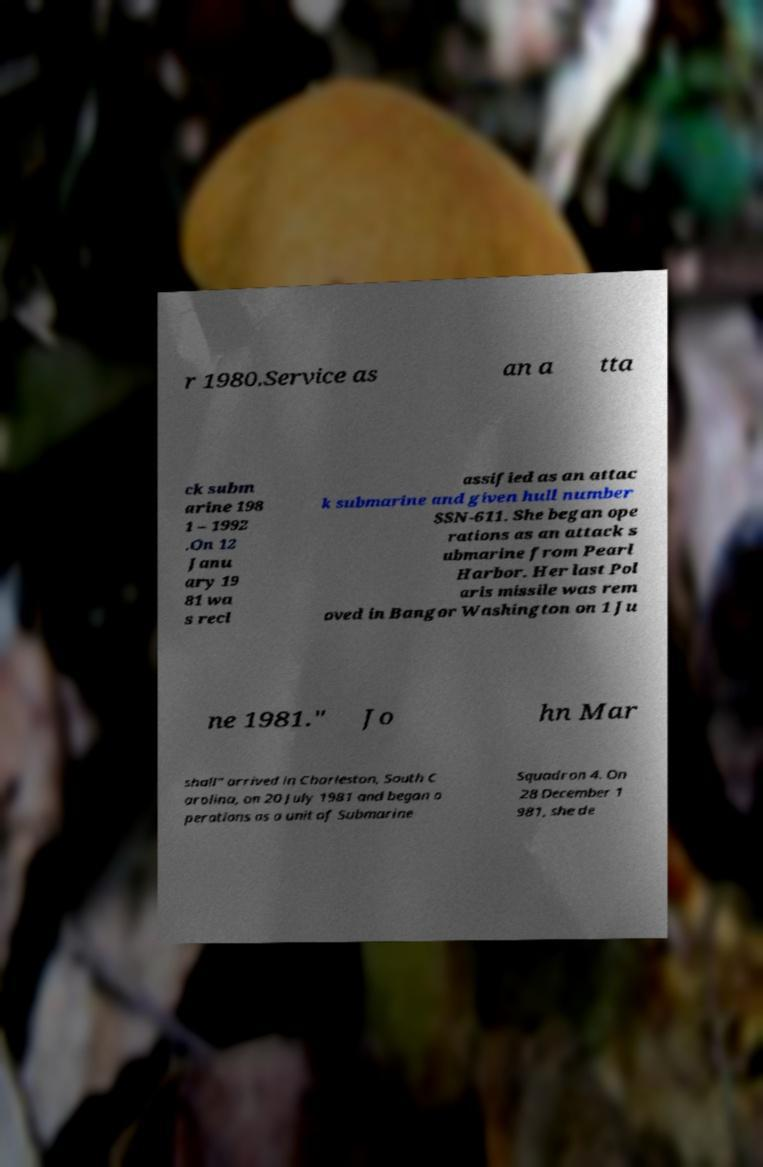There's text embedded in this image that I need extracted. Can you transcribe it verbatim? r 1980.Service as an a tta ck subm arine 198 1 – 1992 .On 12 Janu ary 19 81 wa s recl assified as an attac k submarine and given hull number SSN-611. She began ope rations as an attack s ubmarine from Pearl Harbor. Her last Pol aris missile was rem oved in Bangor Washington on 1 Ju ne 1981." Jo hn Mar shall" arrived in Charleston, South C arolina, on 20 July 1981 and began o perations as a unit of Submarine Squadron 4. On 28 December 1 981, she de 